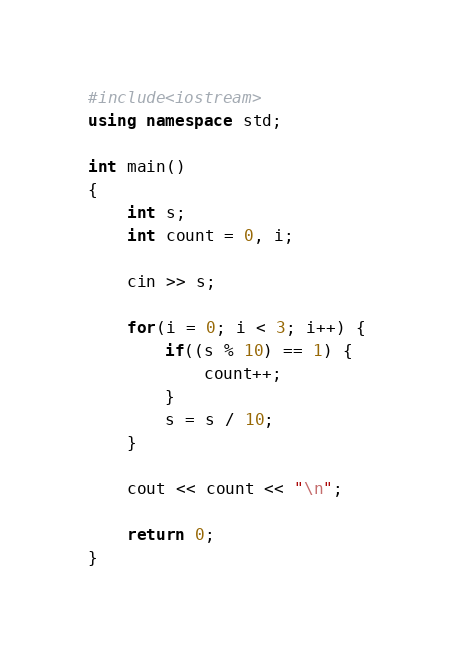Convert code to text. <code><loc_0><loc_0><loc_500><loc_500><_C++_>#include<iostream>
using namespace std;

int main()
{
    int s;
    int count = 0, i;
    
    cin >> s;
    
    for(i = 0; i < 3; i++) {
        if((s % 10) == 1) {
            count++;
        }
        s = s / 10;
    }
    
    cout << count << "\n";
    
    return 0;
}</code> 